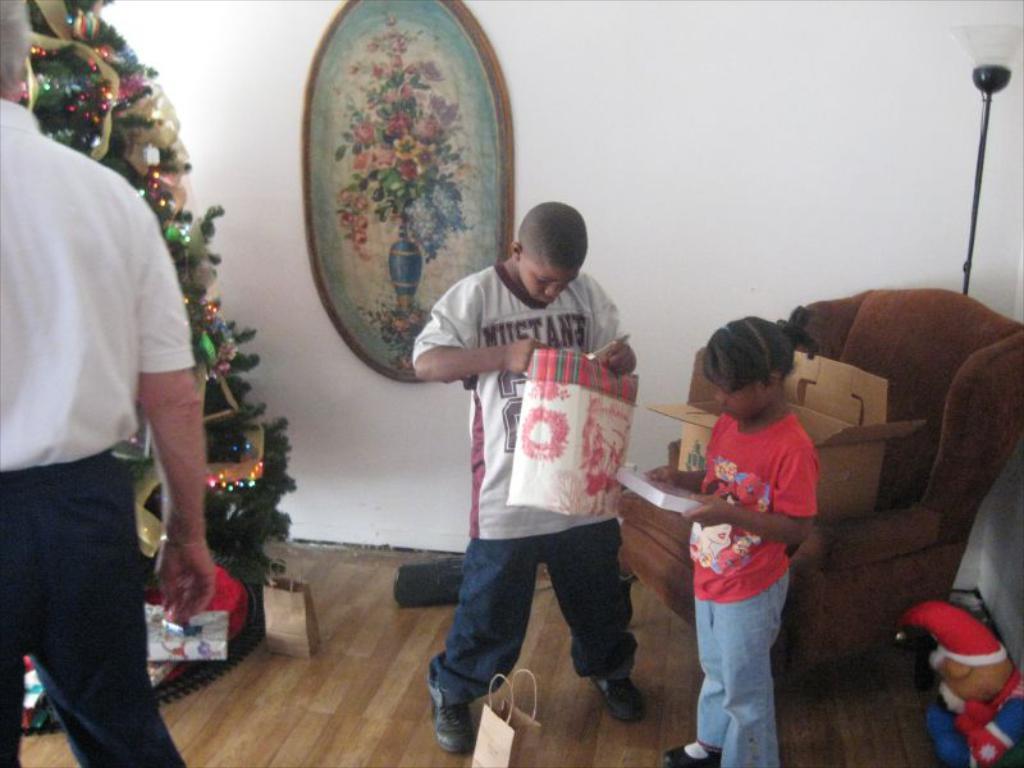Please provide a concise description of this image. In this image there are two children and a person in the room, the children are holding boxes, there is a cardboard box on the sofa, a light, a frame attached to the wall, few carry bags on the floor, a toy on the stand and the Christmas tree. 